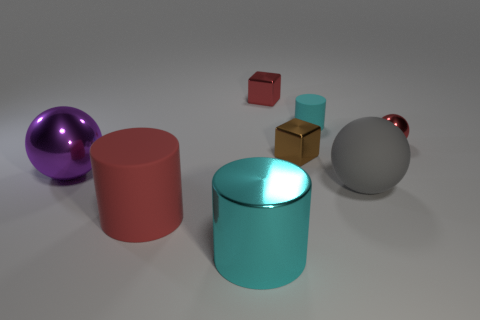Add 1 big green cubes. How many objects exist? 9 Subtract all cylinders. How many objects are left? 5 Subtract 0 green cylinders. How many objects are left? 8 Subtract all cyan things. Subtract all purple objects. How many objects are left? 5 Add 1 rubber balls. How many rubber balls are left? 2 Add 5 small brown metal cubes. How many small brown metal cubes exist? 6 